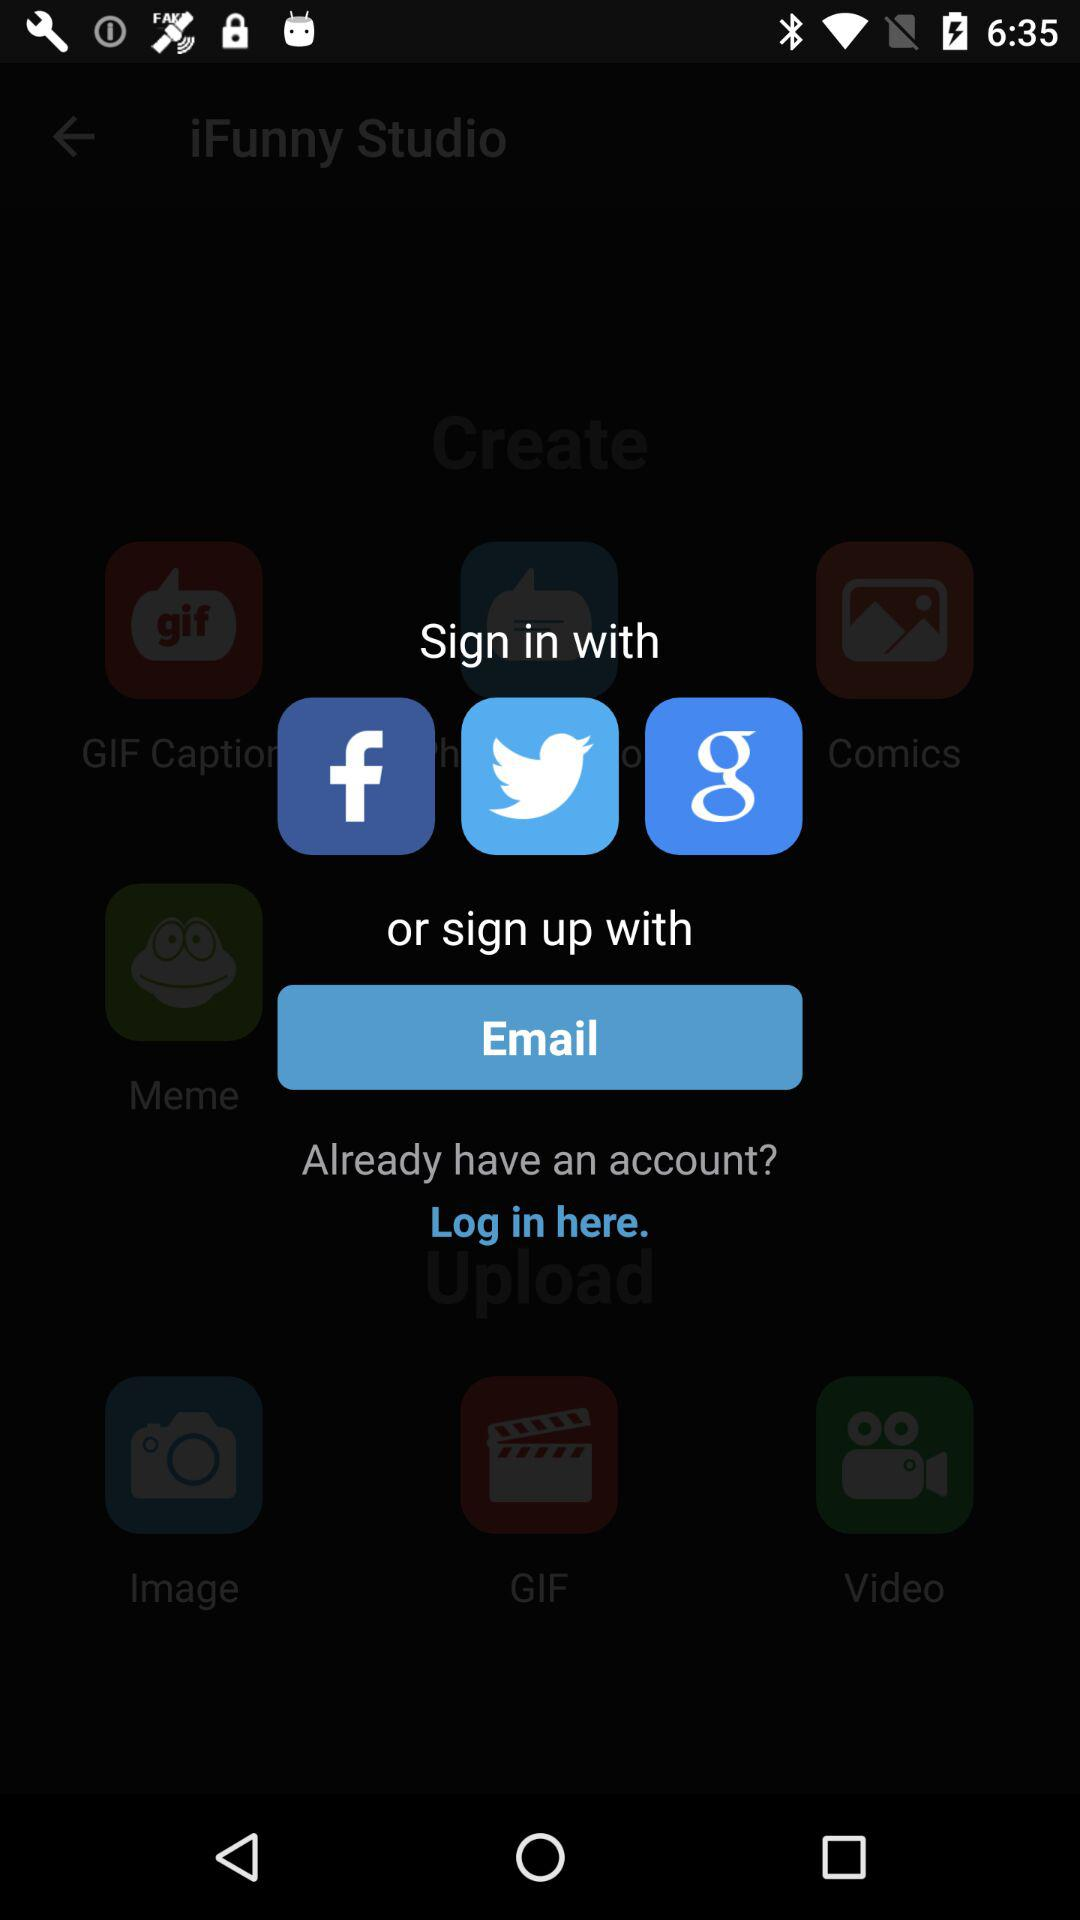What accounts can I use to sign in? The accounts you can use to sign in are "Facebook", "Twitter", "Google" and "Email". 